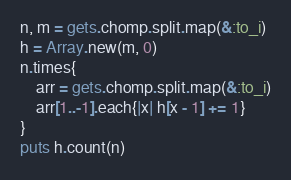<code> <loc_0><loc_0><loc_500><loc_500><_Ruby_>n, m = gets.chomp.split.map(&:to_i)
h = Array.new(m, 0)
n.times{
    arr = gets.chomp.split.map(&:to_i)
    arr[1..-1].each{|x| h[x - 1] += 1}
}
puts h.count(n)</code> 